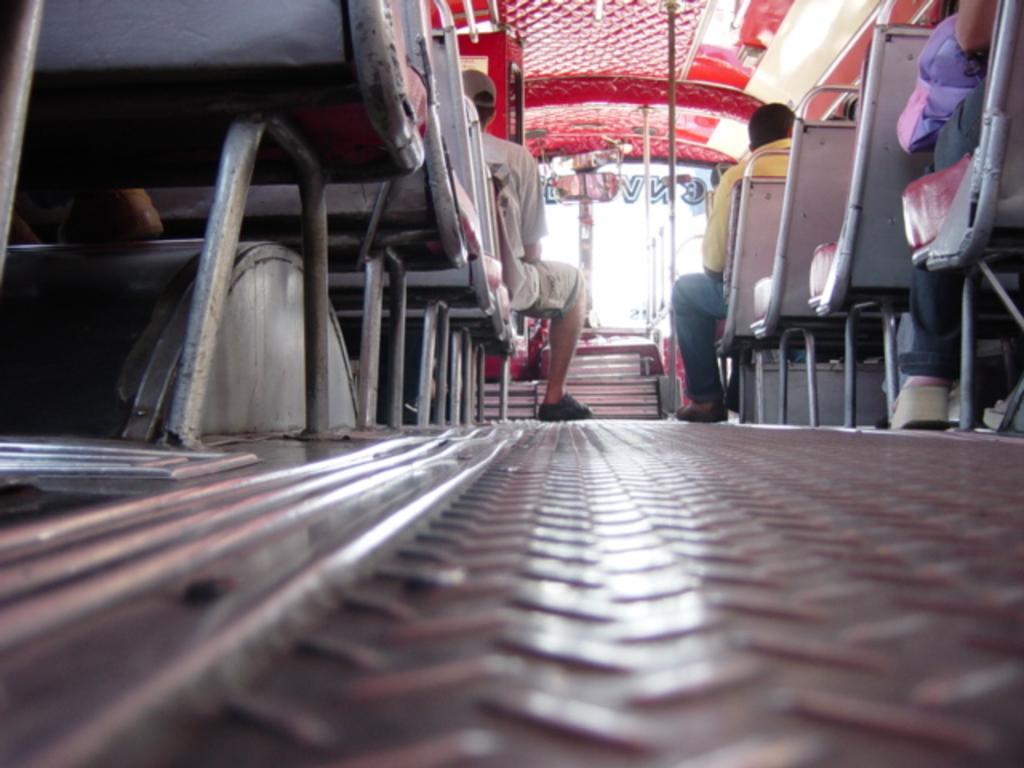How would you summarize this image in a sentence or two? In this image we can see few people sitting in the vehicle, there are rods, a mirror and text on the glass of the vehicle. 